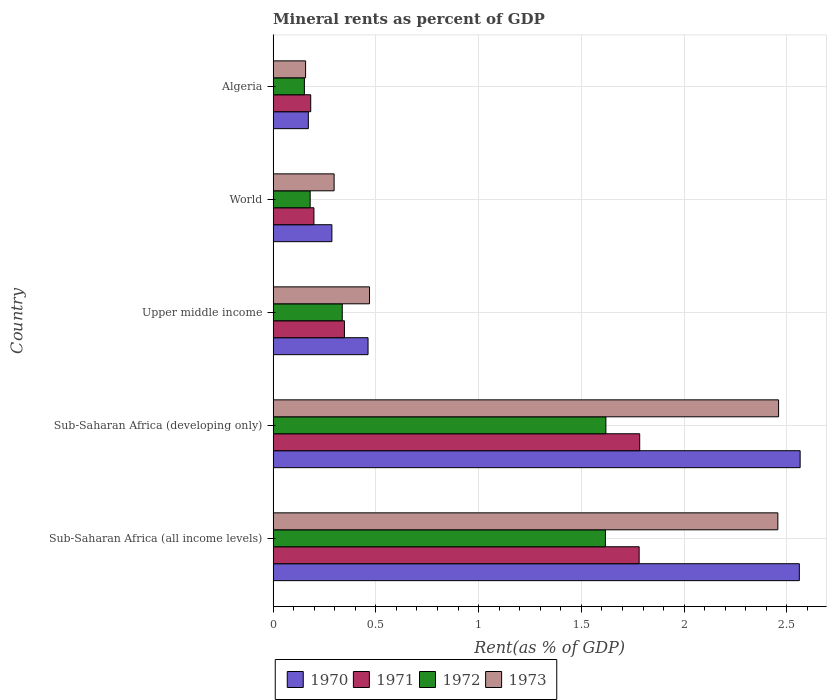How many different coloured bars are there?
Offer a very short reply. 4. Are the number of bars on each tick of the Y-axis equal?
Provide a short and direct response. Yes. How many bars are there on the 1st tick from the bottom?
Your answer should be compact. 4. What is the label of the 4th group of bars from the top?
Keep it short and to the point. Sub-Saharan Africa (developing only). In how many cases, is the number of bars for a given country not equal to the number of legend labels?
Your answer should be compact. 0. What is the mineral rent in 1973 in Sub-Saharan Africa (all income levels)?
Keep it short and to the point. 2.46. Across all countries, what is the maximum mineral rent in 1970?
Offer a terse response. 2.56. Across all countries, what is the minimum mineral rent in 1971?
Your response must be concise. 0.18. In which country was the mineral rent in 1971 maximum?
Provide a short and direct response. Sub-Saharan Africa (developing only). In which country was the mineral rent in 1973 minimum?
Make the answer very short. Algeria. What is the total mineral rent in 1971 in the graph?
Your response must be concise. 4.29. What is the difference between the mineral rent in 1971 in Algeria and that in World?
Your answer should be very brief. -0.02. What is the difference between the mineral rent in 1971 in World and the mineral rent in 1970 in Upper middle income?
Your answer should be very brief. -0.26. What is the average mineral rent in 1973 per country?
Keep it short and to the point. 1.17. What is the difference between the mineral rent in 1972 and mineral rent in 1971 in World?
Offer a very short reply. -0.02. What is the ratio of the mineral rent in 1972 in Sub-Saharan Africa (all income levels) to that in World?
Keep it short and to the point. 8.97. Is the mineral rent in 1972 in Sub-Saharan Africa (all income levels) less than that in World?
Provide a succinct answer. No. What is the difference between the highest and the second highest mineral rent in 1970?
Your response must be concise. 0. What is the difference between the highest and the lowest mineral rent in 1972?
Offer a very short reply. 1.47. Is it the case that in every country, the sum of the mineral rent in 1972 and mineral rent in 1970 is greater than the sum of mineral rent in 1971 and mineral rent in 1973?
Keep it short and to the point. No. What does the 1st bar from the top in Upper middle income represents?
Keep it short and to the point. 1973. What does the 2nd bar from the bottom in Algeria represents?
Give a very brief answer. 1971. Is it the case that in every country, the sum of the mineral rent in 1973 and mineral rent in 1972 is greater than the mineral rent in 1971?
Make the answer very short. Yes. Are all the bars in the graph horizontal?
Offer a very short reply. Yes. What is the difference between two consecutive major ticks on the X-axis?
Give a very brief answer. 0.5. Are the values on the major ticks of X-axis written in scientific E-notation?
Give a very brief answer. No. Where does the legend appear in the graph?
Offer a terse response. Bottom center. How many legend labels are there?
Offer a terse response. 4. How are the legend labels stacked?
Ensure brevity in your answer.  Horizontal. What is the title of the graph?
Offer a very short reply. Mineral rents as percent of GDP. Does "1974" appear as one of the legend labels in the graph?
Provide a short and direct response. No. What is the label or title of the X-axis?
Offer a terse response. Rent(as % of GDP). What is the Rent(as % of GDP) in 1970 in Sub-Saharan Africa (all income levels)?
Keep it short and to the point. 2.56. What is the Rent(as % of GDP) of 1971 in Sub-Saharan Africa (all income levels)?
Make the answer very short. 1.78. What is the Rent(as % of GDP) in 1972 in Sub-Saharan Africa (all income levels)?
Provide a short and direct response. 1.62. What is the Rent(as % of GDP) in 1973 in Sub-Saharan Africa (all income levels)?
Your answer should be very brief. 2.46. What is the Rent(as % of GDP) in 1970 in Sub-Saharan Africa (developing only)?
Keep it short and to the point. 2.56. What is the Rent(as % of GDP) in 1971 in Sub-Saharan Africa (developing only)?
Ensure brevity in your answer.  1.78. What is the Rent(as % of GDP) in 1972 in Sub-Saharan Africa (developing only)?
Your response must be concise. 1.62. What is the Rent(as % of GDP) in 1973 in Sub-Saharan Africa (developing only)?
Provide a short and direct response. 2.46. What is the Rent(as % of GDP) of 1970 in Upper middle income?
Offer a very short reply. 0.46. What is the Rent(as % of GDP) in 1971 in Upper middle income?
Provide a short and direct response. 0.35. What is the Rent(as % of GDP) of 1972 in Upper middle income?
Offer a very short reply. 0.34. What is the Rent(as % of GDP) in 1973 in Upper middle income?
Your response must be concise. 0.47. What is the Rent(as % of GDP) of 1970 in World?
Your answer should be compact. 0.29. What is the Rent(as % of GDP) of 1971 in World?
Keep it short and to the point. 0.2. What is the Rent(as % of GDP) in 1972 in World?
Make the answer very short. 0.18. What is the Rent(as % of GDP) of 1973 in World?
Your answer should be very brief. 0.3. What is the Rent(as % of GDP) in 1970 in Algeria?
Offer a very short reply. 0.17. What is the Rent(as % of GDP) of 1971 in Algeria?
Give a very brief answer. 0.18. What is the Rent(as % of GDP) in 1972 in Algeria?
Provide a succinct answer. 0.15. What is the Rent(as % of GDP) in 1973 in Algeria?
Ensure brevity in your answer.  0.16. Across all countries, what is the maximum Rent(as % of GDP) in 1970?
Your response must be concise. 2.56. Across all countries, what is the maximum Rent(as % of GDP) in 1971?
Offer a very short reply. 1.78. Across all countries, what is the maximum Rent(as % of GDP) of 1972?
Make the answer very short. 1.62. Across all countries, what is the maximum Rent(as % of GDP) of 1973?
Your answer should be very brief. 2.46. Across all countries, what is the minimum Rent(as % of GDP) in 1970?
Provide a short and direct response. 0.17. Across all countries, what is the minimum Rent(as % of GDP) in 1971?
Your response must be concise. 0.18. Across all countries, what is the minimum Rent(as % of GDP) of 1972?
Offer a very short reply. 0.15. Across all countries, what is the minimum Rent(as % of GDP) in 1973?
Provide a short and direct response. 0.16. What is the total Rent(as % of GDP) in 1970 in the graph?
Ensure brevity in your answer.  6.04. What is the total Rent(as % of GDP) in 1971 in the graph?
Offer a terse response. 4.29. What is the total Rent(as % of GDP) of 1972 in the graph?
Provide a short and direct response. 3.9. What is the total Rent(as % of GDP) of 1973 in the graph?
Your answer should be compact. 5.84. What is the difference between the Rent(as % of GDP) in 1970 in Sub-Saharan Africa (all income levels) and that in Sub-Saharan Africa (developing only)?
Provide a short and direct response. -0. What is the difference between the Rent(as % of GDP) of 1971 in Sub-Saharan Africa (all income levels) and that in Sub-Saharan Africa (developing only)?
Make the answer very short. -0. What is the difference between the Rent(as % of GDP) in 1972 in Sub-Saharan Africa (all income levels) and that in Sub-Saharan Africa (developing only)?
Your response must be concise. -0. What is the difference between the Rent(as % of GDP) in 1973 in Sub-Saharan Africa (all income levels) and that in Sub-Saharan Africa (developing only)?
Give a very brief answer. -0. What is the difference between the Rent(as % of GDP) in 1970 in Sub-Saharan Africa (all income levels) and that in Upper middle income?
Your answer should be compact. 2.1. What is the difference between the Rent(as % of GDP) of 1971 in Sub-Saharan Africa (all income levels) and that in Upper middle income?
Keep it short and to the point. 1.43. What is the difference between the Rent(as % of GDP) in 1972 in Sub-Saharan Africa (all income levels) and that in Upper middle income?
Make the answer very short. 1.28. What is the difference between the Rent(as % of GDP) in 1973 in Sub-Saharan Africa (all income levels) and that in Upper middle income?
Offer a very short reply. 1.99. What is the difference between the Rent(as % of GDP) in 1970 in Sub-Saharan Africa (all income levels) and that in World?
Make the answer very short. 2.27. What is the difference between the Rent(as % of GDP) in 1971 in Sub-Saharan Africa (all income levels) and that in World?
Your answer should be very brief. 1.58. What is the difference between the Rent(as % of GDP) of 1972 in Sub-Saharan Africa (all income levels) and that in World?
Offer a very short reply. 1.44. What is the difference between the Rent(as % of GDP) of 1973 in Sub-Saharan Africa (all income levels) and that in World?
Make the answer very short. 2.16. What is the difference between the Rent(as % of GDP) of 1970 in Sub-Saharan Africa (all income levels) and that in Algeria?
Offer a very short reply. 2.39. What is the difference between the Rent(as % of GDP) of 1971 in Sub-Saharan Africa (all income levels) and that in Algeria?
Your response must be concise. 1.6. What is the difference between the Rent(as % of GDP) of 1972 in Sub-Saharan Africa (all income levels) and that in Algeria?
Keep it short and to the point. 1.46. What is the difference between the Rent(as % of GDP) of 1973 in Sub-Saharan Africa (all income levels) and that in Algeria?
Give a very brief answer. 2.3. What is the difference between the Rent(as % of GDP) of 1970 in Sub-Saharan Africa (developing only) and that in Upper middle income?
Your response must be concise. 2.1. What is the difference between the Rent(as % of GDP) of 1971 in Sub-Saharan Africa (developing only) and that in Upper middle income?
Keep it short and to the point. 1.44. What is the difference between the Rent(as % of GDP) in 1972 in Sub-Saharan Africa (developing only) and that in Upper middle income?
Keep it short and to the point. 1.28. What is the difference between the Rent(as % of GDP) in 1973 in Sub-Saharan Africa (developing only) and that in Upper middle income?
Your answer should be very brief. 1.99. What is the difference between the Rent(as % of GDP) of 1970 in Sub-Saharan Africa (developing only) and that in World?
Your answer should be very brief. 2.28. What is the difference between the Rent(as % of GDP) in 1971 in Sub-Saharan Africa (developing only) and that in World?
Ensure brevity in your answer.  1.58. What is the difference between the Rent(as % of GDP) of 1972 in Sub-Saharan Africa (developing only) and that in World?
Provide a succinct answer. 1.44. What is the difference between the Rent(as % of GDP) in 1973 in Sub-Saharan Africa (developing only) and that in World?
Provide a short and direct response. 2.16. What is the difference between the Rent(as % of GDP) of 1970 in Sub-Saharan Africa (developing only) and that in Algeria?
Make the answer very short. 2.39. What is the difference between the Rent(as % of GDP) in 1971 in Sub-Saharan Africa (developing only) and that in Algeria?
Provide a short and direct response. 1.6. What is the difference between the Rent(as % of GDP) in 1972 in Sub-Saharan Africa (developing only) and that in Algeria?
Offer a very short reply. 1.47. What is the difference between the Rent(as % of GDP) of 1973 in Sub-Saharan Africa (developing only) and that in Algeria?
Make the answer very short. 2.3. What is the difference between the Rent(as % of GDP) of 1970 in Upper middle income and that in World?
Keep it short and to the point. 0.18. What is the difference between the Rent(as % of GDP) in 1971 in Upper middle income and that in World?
Offer a terse response. 0.15. What is the difference between the Rent(as % of GDP) in 1972 in Upper middle income and that in World?
Ensure brevity in your answer.  0.16. What is the difference between the Rent(as % of GDP) in 1973 in Upper middle income and that in World?
Give a very brief answer. 0.17. What is the difference between the Rent(as % of GDP) of 1970 in Upper middle income and that in Algeria?
Give a very brief answer. 0.29. What is the difference between the Rent(as % of GDP) of 1971 in Upper middle income and that in Algeria?
Your answer should be very brief. 0.16. What is the difference between the Rent(as % of GDP) in 1972 in Upper middle income and that in Algeria?
Your answer should be very brief. 0.18. What is the difference between the Rent(as % of GDP) of 1973 in Upper middle income and that in Algeria?
Your answer should be very brief. 0.31. What is the difference between the Rent(as % of GDP) of 1970 in World and that in Algeria?
Keep it short and to the point. 0.11. What is the difference between the Rent(as % of GDP) in 1971 in World and that in Algeria?
Offer a terse response. 0.02. What is the difference between the Rent(as % of GDP) of 1972 in World and that in Algeria?
Your answer should be compact. 0.03. What is the difference between the Rent(as % of GDP) in 1973 in World and that in Algeria?
Keep it short and to the point. 0.14. What is the difference between the Rent(as % of GDP) in 1970 in Sub-Saharan Africa (all income levels) and the Rent(as % of GDP) in 1971 in Sub-Saharan Africa (developing only)?
Keep it short and to the point. 0.78. What is the difference between the Rent(as % of GDP) of 1970 in Sub-Saharan Africa (all income levels) and the Rent(as % of GDP) of 1973 in Sub-Saharan Africa (developing only)?
Keep it short and to the point. 0.1. What is the difference between the Rent(as % of GDP) in 1971 in Sub-Saharan Africa (all income levels) and the Rent(as % of GDP) in 1972 in Sub-Saharan Africa (developing only)?
Offer a terse response. 0.16. What is the difference between the Rent(as % of GDP) of 1971 in Sub-Saharan Africa (all income levels) and the Rent(as % of GDP) of 1973 in Sub-Saharan Africa (developing only)?
Provide a succinct answer. -0.68. What is the difference between the Rent(as % of GDP) of 1972 in Sub-Saharan Africa (all income levels) and the Rent(as % of GDP) of 1973 in Sub-Saharan Africa (developing only)?
Your answer should be compact. -0.84. What is the difference between the Rent(as % of GDP) of 1970 in Sub-Saharan Africa (all income levels) and the Rent(as % of GDP) of 1971 in Upper middle income?
Offer a very short reply. 2.21. What is the difference between the Rent(as % of GDP) of 1970 in Sub-Saharan Africa (all income levels) and the Rent(as % of GDP) of 1972 in Upper middle income?
Ensure brevity in your answer.  2.22. What is the difference between the Rent(as % of GDP) in 1970 in Sub-Saharan Africa (all income levels) and the Rent(as % of GDP) in 1973 in Upper middle income?
Your response must be concise. 2.09. What is the difference between the Rent(as % of GDP) of 1971 in Sub-Saharan Africa (all income levels) and the Rent(as % of GDP) of 1972 in Upper middle income?
Make the answer very short. 1.44. What is the difference between the Rent(as % of GDP) in 1971 in Sub-Saharan Africa (all income levels) and the Rent(as % of GDP) in 1973 in Upper middle income?
Your answer should be compact. 1.31. What is the difference between the Rent(as % of GDP) in 1972 in Sub-Saharan Africa (all income levels) and the Rent(as % of GDP) in 1973 in Upper middle income?
Give a very brief answer. 1.15. What is the difference between the Rent(as % of GDP) in 1970 in Sub-Saharan Africa (all income levels) and the Rent(as % of GDP) in 1971 in World?
Provide a succinct answer. 2.36. What is the difference between the Rent(as % of GDP) of 1970 in Sub-Saharan Africa (all income levels) and the Rent(as % of GDP) of 1972 in World?
Your answer should be very brief. 2.38. What is the difference between the Rent(as % of GDP) in 1970 in Sub-Saharan Africa (all income levels) and the Rent(as % of GDP) in 1973 in World?
Make the answer very short. 2.26. What is the difference between the Rent(as % of GDP) in 1971 in Sub-Saharan Africa (all income levels) and the Rent(as % of GDP) in 1972 in World?
Offer a terse response. 1.6. What is the difference between the Rent(as % of GDP) of 1971 in Sub-Saharan Africa (all income levels) and the Rent(as % of GDP) of 1973 in World?
Your answer should be compact. 1.48. What is the difference between the Rent(as % of GDP) in 1972 in Sub-Saharan Africa (all income levels) and the Rent(as % of GDP) in 1973 in World?
Ensure brevity in your answer.  1.32. What is the difference between the Rent(as % of GDP) in 1970 in Sub-Saharan Africa (all income levels) and the Rent(as % of GDP) in 1971 in Algeria?
Your response must be concise. 2.38. What is the difference between the Rent(as % of GDP) of 1970 in Sub-Saharan Africa (all income levels) and the Rent(as % of GDP) of 1972 in Algeria?
Your answer should be very brief. 2.41. What is the difference between the Rent(as % of GDP) in 1970 in Sub-Saharan Africa (all income levels) and the Rent(as % of GDP) in 1973 in Algeria?
Your response must be concise. 2.4. What is the difference between the Rent(as % of GDP) of 1971 in Sub-Saharan Africa (all income levels) and the Rent(as % of GDP) of 1972 in Algeria?
Your answer should be compact. 1.63. What is the difference between the Rent(as % of GDP) in 1971 in Sub-Saharan Africa (all income levels) and the Rent(as % of GDP) in 1973 in Algeria?
Provide a short and direct response. 1.62. What is the difference between the Rent(as % of GDP) of 1972 in Sub-Saharan Africa (all income levels) and the Rent(as % of GDP) of 1973 in Algeria?
Your answer should be very brief. 1.46. What is the difference between the Rent(as % of GDP) in 1970 in Sub-Saharan Africa (developing only) and the Rent(as % of GDP) in 1971 in Upper middle income?
Offer a terse response. 2.22. What is the difference between the Rent(as % of GDP) in 1970 in Sub-Saharan Africa (developing only) and the Rent(as % of GDP) in 1972 in Upper middle income?
Provide a short and direct response. 2.23. What is the difference between the Rent(as % of GDP) of 1970 in Sub-Saharan Africa (developing only) and the Rent(as % of GDP) of 1973 in Upper middle income?
Ensure brevity in your answer.  2.1. What is the difference between the Rent(as % of GDP) in 1971 in Sub-Saharan Africa (developing only) and the Rent(as % of GDP) in 1972 in Upper middle income?
Your answer should be very brief. 1.45. What is the difference between the Rent(as % of GDP) of 1971 in Sub-Saharan Africa (developing only) and the Rent(as % of GDP) of 1973 in Upper middle income?
Give a very brief answer. 1.31. What is the difference between the Rent(as % of GDP) in 1972 in Sub-Saharan Africa (developing only) and the Rent(as % of GDP) in 1973 in Upper middle income?
Make the answer very short. 1.15. What is the difference between the Rent(as % of GDP) of 1970 in Sub-Saharan Africa (developing only) and the Rent(as % of GDP) of 1971 in World?
Offer a terse response. 2.37. What is the difference between the Rent(as % of GDP) in 1970 in Sub-Saharan Africa (developing only) and the Rent(as % of GDP) in 1972 in World?
Provide a succinct answer. 2.38. What is the difference between the Rent(as % of GDP) in 1970 in Sub-Saharan Africa (developing only) and the Rent(as % of GDP) in 1973 in World?
Ensure brevity in your answer.  2.27. What is the difference between the Rent(as % of GDP) of 1971 in Sub-Saharan Africa (developing only) and the Rent(as % of GDP) of 1972 in World?
Offer a terse response. 1.6. What is the difference between the Rent(as % of GDP) of 1971 in Sub-Saharan Africa (developing only) and the Rent(as % of GDP) of 1973 in World?
Your response must be concise. 1.49. What is the difference between the Rent(as % of GDP) of 1972 in Sub-Saharan Africa (developing only) and the Rent(as % of GDP) of 1973 in World?
Your answer should be compact. 1.32. What is the difference between the Rent(as % of GDP) in 1970 in Sub-Saharan Africa (developing only) and the Rent(as % of GDP) in 1971 in Algeria?
Make the answer very short. 2.38. What is the difference between the Rent(as % of GDP) in 1970 in Sub-Saharan Africa (developing only) and the Rent(as % of GDP) in 1972 in Algeria?
Offer a terse response. 2.41. What is the difference between the Rent(as % of GDP) of 1970 in Sub-Saharan Africa (developing only) and the Rent(as % of GDP) of 1973 in Algeria?
Ensure brevity in your answer.  2.41. What is the difference between the Rent(as % of GDP) in 1971 in Sub-Saharan Africa (developing only) and the Rent(as % of GDP) in 1972 in Algeria?
Offer a very short reply. 1.63. What is the difference between the Rent(as % of GDP) in 1971 in Sub-Saharan Africa (developing only) and the Rent(as % of GDP) in 1973 in Algeria?
Ensure brevity in your answer.  1.63. What is the difference between the Rent(as % of GDP) in 1972 in Sub-Saharan Africa (developing only) and the Rent(as % of GDP) in 1973 in Algeria?
Offer a terse response. 1.46. What is the difference between the Rent(as % of GDP) of 1970 in Upper middle income and the Rent(as % of GDP) of 1971 in World?
Offer a terse response. 0.26. What is the difference between the Rent(as % of GDP) in 1970 in Upper middle income and the Rent(as % of GDP) in 1972 in World?
Provide a succinct answer. 0.28. What is the difference between the Rent(as % of GDP) in 1970 in Upper middle income and the Rent(as % of GDP) in 1973 in World?
Offer a very short reply. 0.17. What is the difference between the Rent(as % of GDP) in 1971 in Upper middle income and the Rent(as % of GDP) in 1973 in World?
Ensure brevity in your answer.  0.05. What is the difference between the Rent(as % of GDP) of 1972 in Upper middle income and the Rent(as % of GDP) of 1973 in World?
Provide a succinct answer. 0.04. What is the difference between the Rent(as % of GDP) in 1970 in Upper middle income and the Rent(as % of GDP) in 1971 in Algeria?
Provide a short and direct response. 0.28. What is the difference between the Rent(as % of GDP) in 1970 in Upper middle income and the Rent(as % of GDP) in 1972 in Algeria?
Your response must be concise. 0.31. What is the difference between the Rent(as % of GDP) of 1970 in Upper middle income and the Rent(as % of GDP) of 1973 in Algeria?
Your answer should be compact. 0.3. What is the difference between the Rent(as % of GDP) of 1971 in Upper middle income and the Rent(as % of GDP) of 1972 in Algeria?
Ensure brevity in your answer.  0.19. What is the difference between the Rent(as % of GDP) of 1971 in Upper middle income and the Rent(as % of GDP) of 1973 in Algeria?
Ensure brevity in your answer.  0.19. What is the difference between the Rent(as % of GDP) in 1972 in Upper middle income and the Rent(as % of GDP) in 1973 in Algeria?
Ensure brevity in your answer.  0.18. What is the difference between the Rent(as % of GDP) of 1970 in World and the Rent(as % of GDP) of 1971 in Algeria?
Your answer should be compact. 0.1. What is the difference between the Rent(as % of GDP) in 1970 in World and the Rent(as % of GDP) in 1972 in Algeria?
Ensure brevity in your answer.  0.13. What is the difference between the Rent(as % of GDP) in 1970 in World and the Rent(as % of GDP) in 1973 in Algeria?
Make the answer very short. 0.13. What is the difference between the Rent(as % of GDP) of 1971 in World and the Rent(as % of GDP) of 1972 in Algeria?
Provide a succinct answer. 0.05. What is the difference between the Rent(as % of GDP) in 1971 in World and the Rent(as % of GDP) in 1973 in Algeria?
Make the answer very short. 0.04. What is the difference between the Rent(as % of GDP) of 1972 in World and the Rent(as % of GDP) of 1973 in Algeria?
Make the answer very short. 0.02. What is the average Rent(as % of GDP) of 1970 per country?
Provide a succinct answer. 1.21. What is the average Rent(as % of GDP) of 1971 per country?
Give a very brief answer. 0.86. What is the average Rent(as % of GDP) of 1972 per country?
Your response must be concise. 0.78. What is the average Rent(as % of GDP) of 1973 per country?
Keep it short and to the point. 1.17. What is the difference between the Rent(as % of GDP) of 1970 and Rent(as % of GDP) of 1971 in Sub-Saharan Africa (all income levels)?
Provide a short and direct response. 0.78. What is the difference between the Rent(as % of GDP) in 1970 and Rent(as % of GDP) in 1972 in Sub-Saharan Africa (all income levels)?
Your answer should be very brief. 0.94. What is the difference between the Rent(as % of GDP) in 1970 and Rent(as % of GDP) in 1973 in Sub-Saharan Africa (all income levels)?
Offer a terse response. 0.1. What is the difference between the Rent(as % of GDP) of 1971 and Rent(as % of GDP) of 1972 in Sub-Saharan Africa (all income levels)?
Ensure brevity in your answer.  0.16. What is the difference between the Rent(as % of GDP) of 1971 and Rent(as % of GDP) of 1973 in Sub-Saharan Africa (all income levels)?
Make the answer very short. -0.67. What is the difference between the Rent(as % of GDP) in 1972 and Rent(as % of GDP) in 1973 in Sub-Saharan Africa (all income levels)?
Give a very brief answer. -0.84. What is the difference between the Rent(as % of GDP) of 1970 and Rent(as % of GDP) of 1971 in Sub-Saharan Africa (developing only)?
Your response must be concise. 0.78. What is the difference between the Rent(as % of GDP) in 1970 and Rent(as % of GDP) in 1972 in Sub-Saharan Africa (developing only)?
Provide a short and direct response. 0.95. What is the difference between the Rent(as % of GDP) in 1970 and Rent(as % of GDP) in 1973 in Sub-Saharan Africa (developing only)?
Keep it short and to the point. 0.1. What is the difference between the Rent(as % of GDP) of 1971 and Rent(as % of GDP) of 1972 in Sub-Saharan Africa (developing only)?
Offer a very short reply. 0.16. What is the difference between the Rent(as % of GDP) of 1971 and Rent(as % of GDP) of 1973 in Sub-Saharan Africa (developing only)?
Your response must be concise. -0.68. What is the difference between the Rent(as % of GDP) of 1972 and Rent(as % of GDP) of 1973 in Sub-Saharan Africa (developing only)?
Keep it short and to the point. -0.84. What is the difference between the Rent(as % of GDP) of 1970 and Rent(as % of GDP) of 1971 in Upper middle income?
Your answer should be very brief. 0.11. What is the difference between the Rent(as % of GDP) in 1970 and Rent(as % of GDP) in 1972 in Upper middle income?
Your answer should be compact. 0.13. What is the difference between the Rent(as % of GDP) in 1970 and Rent(as % of GDP) in 1973 in Upper middle income?
Offer a terse response. -0.01. What is the difference between the Rent(as % of GDP) of 1971 and Rent(as % of GDP) of 1972 in Upper middle income?
Make the answer very short. 0.01. What is the difference between the Rent(as % of GDP) in 1971 and Rent(as % of GDP) in 1973 in Upper middle income?
Provide a succinct answer. -0.12. What is the difference between the Rent(as % of GDP) of 1972 and Rent(as % of GDP) of 1973 in Upper middle income?
Offer a terse response. -0.13. What is the difference between the Rent(as % of GDP) of 1970 and Rent(as % of GDP) of 1971 in World?
Your answer should be very brief. 0.09. What is the difference between the Rent(as % of GDP) of 1970 and Rent(as % of GDP) of 1972 in World?
Make the answer very short. 0.11. What is the difference between the Rent(as % of GDP) of 1970 and Rent(as % of GDP) of 1973 in World?
Offer a terse response. -0.01. What is the difference between the Rent(as % of GDP) of 1971 and Rent(as % of GDP) of 1972 in World?
Ensure brevity in your answer.  0.02. What is the difference between the Rent(as % of GDP) of 1971 and Rent(as % of GDP) of 1973 in World?
Provide a short and direct response. -0.1. What is the difference between the Rent(as % of GDP) of 1972 and Rent(as % of GDP) of 1973 in World?
Make the answer very short. -0.12. What is the difference between the Rent(as % of GDP) of 1970 and Rent(as % of GDP) of 1971 in Algeria?
Make the answer very short. -0.01. What is the difference between the Rent(as % of GDP) in 1970 and Rent(as % of GDP) in 1972 in Algeria?
Your answer should be compact. 0.02. What is the difference between the Rent(as % of GDP) in 1970 and Rent(as % of GDP) in 1973 in Algeria?
Provide a succinct answer. 0.01. What is the difference between the Rent(as % of GDP) in 1971 and Rent(as % of GDP) in 1972 in Algeria?
Give a very brief answer. 0.03. What is the difference between the Rent(as % of GDP) of 1971 and Rent(as % of GDP) of 1973 in Algeria?
Make the answer very short. 0.03. What is the difference between the Rent(as % of GDP) in 1972 and Rent(as % of GDP) in 1973 in Algeria?
Keep it short and to the point. -0.01. What is the ratio of the Rent(as % of GDP) in 1971 in Sub-Saharan Africa (all income levels) to that in Sub-Saharan Africa (developing only)?
Offer a terse response. 1. What is the ratio of the Rent(as % of GDP) of 1972 in Sub-Saharan Africa (all income levels) to that in Sub-Saharan Africa (developing only)?
Offer a terse response. 1. What is the ratio of the Rent(as % of GDP) in 1973 in Sub-Saharan Africa (all income levels) to that in Sub-Saharan Africa (developing only)?
Provide a succinct answer. 1. What is the ratio of the Rent(as % of GDP) of 1970 in Sub-Saharan Africa (all income levels) to that in Upper middle income?
Ensure brevity in your answer.  5.54. What is the ratio of the Rent(as % of GDP) in 1971 in Sub-Saharan Africa (all income levels) to that in Upper middle income?
Your response must be concise. 5.13. What is the ratio of the Rent(as % of GDP) in 1972 in Sub-Saharan Africa (all income levels) to that in Upper middle income?
Provide a succinct answer. 4.81. What is the ratio of the Rent(as % of GDP) in 1973 in Sub-Saharan Africa (all income levels) to that in Upper middle income?
Ensure brevity in your answer.  5.24. What is the ratio of the Rent(as % of GDP) in 1970 in Sub-Saharan Africa (all income levels) to that in World?
Provide a short and direct response. 8.95. What is the ratio of the Rent(as % of GDP) of 1971 in Sub-Saharan Africa (all income levels) to that in World?
Offer a very short reply. 8.97. What is the ratio of the Rent(as % of GDP) of 1972 in Sub-Saharan Africa (all income levels) to that in World?
Your answer should be compact. 8.97. What is the ratio of the Rent(as % of GDP) in 1973 in Sub-Saharan Africa (all income levels) to that in World?
Your response must be concise. 8.28. What is the ratio of the Rent(as % of GDP) of 1970 in Sub-Saharan Africa (all income levels) to that in Algeria?
Ensure brevity in your answer.  14.94. What is the ratio of the Rent(as % of GDP) in 1971 in Sub-Saharan Africa (all income levels) to that in Algeria?
Provide a short and direct response. 9.74. What is the ratio of the Rent(as % of GDP) of 1972 in Sub-Saharan Africa (all income levels) to that in Algeria?
Ensure brevity in your answer.  10.62. What is the ratio of the Rent(as % of GDP) in 1973 in Sub-Saharan Africa (all income levels) to that in Algeria?
Offer a very short reply. 15.55. What is the ratio of the Rent(as % of GDP) in 1970 in Sub-Saharan Africa (developing only) to that in Upper middle income?
Provide a succinct answer. 5.55. What is the ratio of the Rent(as % of GDP) of 1971 in Sub-Saharan Africa (developing only) to that in Upper middle income?
Give a very brief answer. 5.14. What is the ratio of the Rent(as % of GDP) of 1972 in Sub-Saharan Africa (developing only) to that in Upper middle income?
Your answer should be compact. 4.81. What is the ratio of the Rent(as % of GDP) of 1973 in Sub-Saharan Africa (developing only) to that in Upper middle income?
Your answer should be compact. 5.24. What is the ratio of the Rent(as % of GDP) in 1970 in Sub-Saharan Africa (developing only) to that in World?
Provide a succinct answer. 8.97. What is the ratio of the Rent(as % of GDP) in 1971 in Sub-Saharan Africa (developing only) to that in World?
Ensure brevity in your answer.  8.98. What is the ratio of the Rent(as % of GDP) of 1972 in Sub-Saharan Africa (developing only) to that in World?
Ensure brevity in your answer.  8.98. What is the ratio of the Rent(as % of GDP) of 1973 in Sub-Saharan Africa (developing only) to that in World?
Give a very brief answer. 8.29. What is the ratio of the Rent(as % of GDP) of 1970 in Sub-Saharan Africa (developing only) to that in Algeria?
Provide a short and direct response. 14.96. What is the ratio of the Rent(as % of GDP) of 1971 in Sub-Saharan Africa (developing only) to that in Algeria?
Keep it short and to the point. 9.75. What is the ratio of the Rent(as % of GDP) in 1972 in Sub-Saharan Africa (developing only) to that in Algeria?
Offer a terse response. 10.64. What is the ratio of the Rent(as % of GDP) in 1973 in Sub-Saharan Africa (developing only) to that in Algeria?
Offer a terse response. 15.57. What is the ratio of the Rent(as % of GDP) of 1970 in Upper middle income to that in World?
Your answer should be compact. 1.62. What is the ratio of the Rent(as % of GDP) of 1971 in Upper middle income to that in World?
Provide a succinct answer. 1.75. What is the ratio of the Rent(as % of GDP) in 1972 in Upper middle income to that in World?
Offer a terse response. 1.87. What is the ratio of the Rent(as % of GDP) of 1973 in Upper middle income to that in World?
Ensure brevity in your answer.  1.58. What is the ratio of the Rent(as % of GDP) in 1970 in Upper middle income to that in Algeria?
Offer a very short reply. 2.69. What is the ratio of the Rent(as % of GDP) in 1971 in Upper middle income to that in Algeria?
Provide a succinct answer. 1.9. What is the ratio of the Rent(as % of GDP) in 1972 in Upper middle income to that in Algeria?
Your answer should be compact. 2.21. What is the ratio of the Rent(as % of GDP) in 1973 in Upper middle income to that in Algeria?
Keep it short and to the point. 2.97. What is the ratio of the Rent(as % of GDP) in 1970 in World to that in Algeria?
Keep it short and to the point. 1.67. What is the ratio of the Rent(as % of GDP) of 1971 in World to that in Algeria?
Provide a succinct answer. 1.09. What is the ratio of the Rent(as % of GDP) of 1972 in World to that in Algeria?
Make the answer very short. 1.18. What is the ratio of the Rent(as % of GDP) in 1973 in World to that in Algeria?
Give a very brief answer. 1.88. What is the difference between the highest and the second highest Rent(as % of GDP) of 1970?
Your answer should be compact. 0. What is the difference between the highest and the second highest Rent(as % of GDP) in 1971?
Your response must be concise. 0. What is the difference between the highest and the second highest Rent(as % of GDP) of 1972?
Your response must be concise. 0. What is the difference between the highest and the second highest Rent(as % of GDP) of 1973?
Provide a succinct answer. 0. What is the difference between the highest and the lowest Rent(as % of GDP) in 1970?
Provide a succinct answer. 2.39. What is the difference between the highest and the lowest Rent(as % of GDP) in 1971?
Keep it short and to the point. 1.6. What is the difference between the highest and the lowest Rent(as % of GDP) of 1972?
Provide a short and direct response. 1.47. What is the difference between the highest and the lowest Rent(as % of GDP) in 1973?
Ensure brevity in your answer.  2.3. 